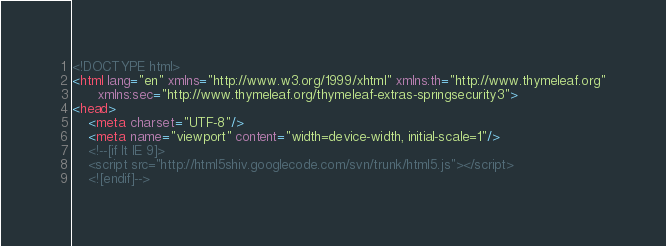<code> <loc_0><loc_0><loc_500><loc_500><_HTML_><!DOCTYPE html>
<html lang="en" xmlns="http://www.w3.org/1999/xhtml" xmlns:th="http://www.thymeleaf.org"
      xmlns:sec="http://www.thymeleaf.org/thymeleaf-extras-springsecurity3">
<head>
    <meta charset="UTF-8"/>
    <meta name="viewport" content="width=device-width, initial-scale=1"/>
    <!--[if lt IE 9]>
    <script src="http://html5shiv.googlecode.com/svn/trunk/html5.js"></script>
    <![endif]--></code> 